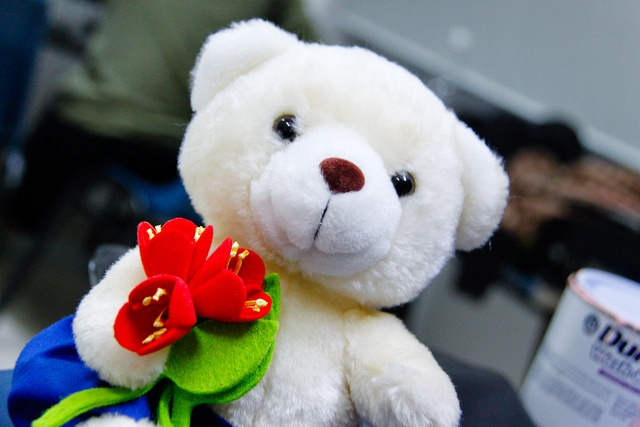Describe the objects in this image and their specific colors. I can see teddy bear in navy, lightgray, darkgray, red, and black tones and people in navy, black, gray, and darkgreen tones in this image. 